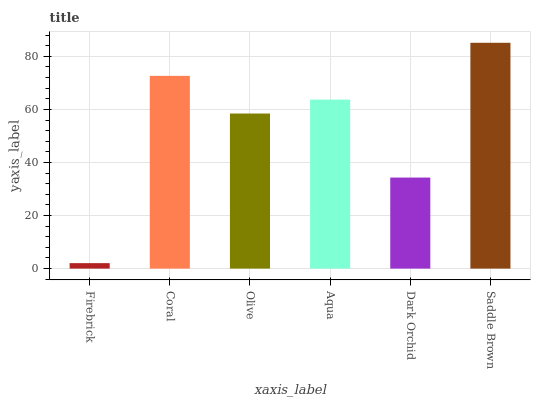Is Firebrick the minimum?
Answer yes or no. Yes. Is Saddle Brown the maximum?
Answer yes or no. Yes. Is Coral the minimum?
Answer yes or no. No. Is Coral the maximum?
Answer yes or no. No. Is Coral greater than Firebrick?
Answer yes or no. Yes. Is Firebrick less than Coral?
Answer yes or no. Yes. Is Firebrick greater than Coral?
Answer yes or no. No. Is Coral less than Firebrick?
Answer yes or no. No. Is Aqua the high median?
Answer yes or no. Yes. Is Olive the low median?
Answer yes or no. Yes. Is Firebrick the high median?
Answer yes or no. No. Is Firebrick the low median?
Answer yes or no. No. 